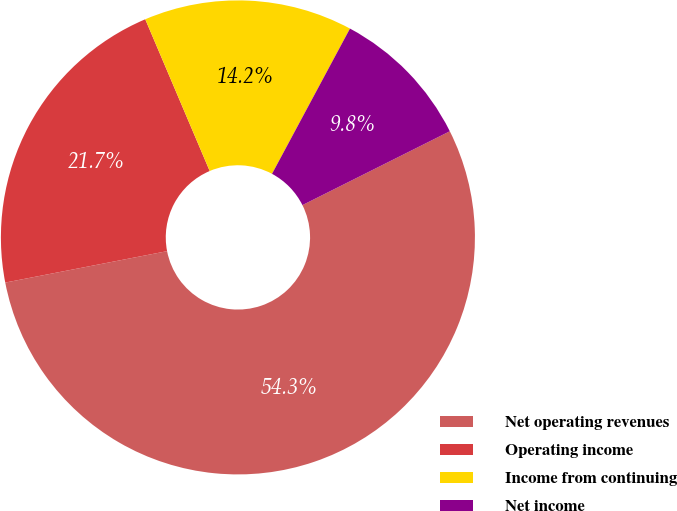Convert chart to OTSL. <chart><loc_0><loc_0><loc_500><loc_500><pie_chart><fcel>Net operating revenues<fcel>Operating income<fcel>Income from continuing<fcel>Net income<nl><fcel>54.34%<fcel>21.66%<fcel>14.23%<fcel>9.77%<nl></chart> 